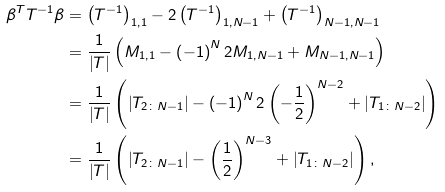<formula> <loc_0><loc_0><loc_500><loc_500>\beta ^ { T } T ^ { - 1 } \beta & = \left ( T ^ { - 1 } \right ) _ { 1 , 1 } - 2 \left ( T ^ { - 1 } \right ) _ { 1 , N - 1 } + \left ( T ^ { - 1 } \right ) _ { N - 1 , N - 1 } \\ & = \frac { 1 } { \left | T \right | } \left ( M _ { 1 , 1 } - \left ( - 1 \right ) ^ { N } 2 M _ { 1 , N - 1 } + M _ { N - 1 , N - 1 } \right ) \\ & = \frac { 1 } { \left | T \right | } \left ( \left | T _ { 2 \colon N - 1 } \right | - \left ( - 1 \right ) ^ { N } 2 \left ( - \frac { 1 } { 2 } \right ) ^ { N - 2 } + \left | T _ { 1 \colon N - 2 } \right | \right ) \\ & = \frac { 1 } { \left | T \right | } \left ( \left | T _ { 2 \colon N - 1 } \right | - \left ( \frac { 1 } { 2 } \right ) ^ { N - 3 } + \left | T _ { 1 \colon N - 2 } \right | \right ) ,</formula> 